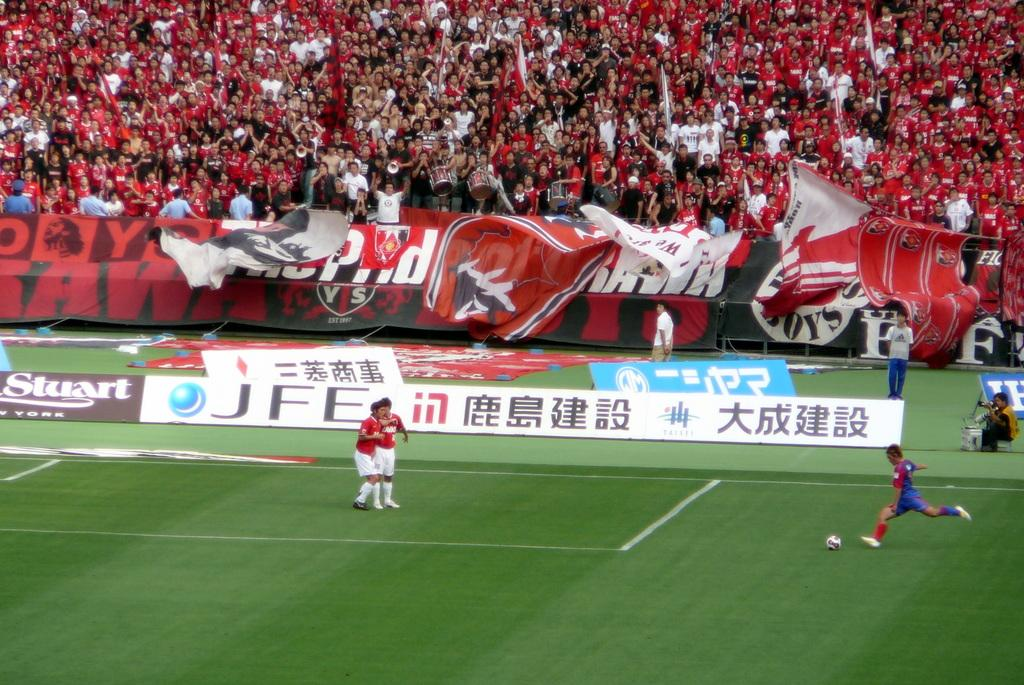<image>
Provide a brief description of the given image. A sign with Asian lettering is on the side of a soccer field with players on it. 